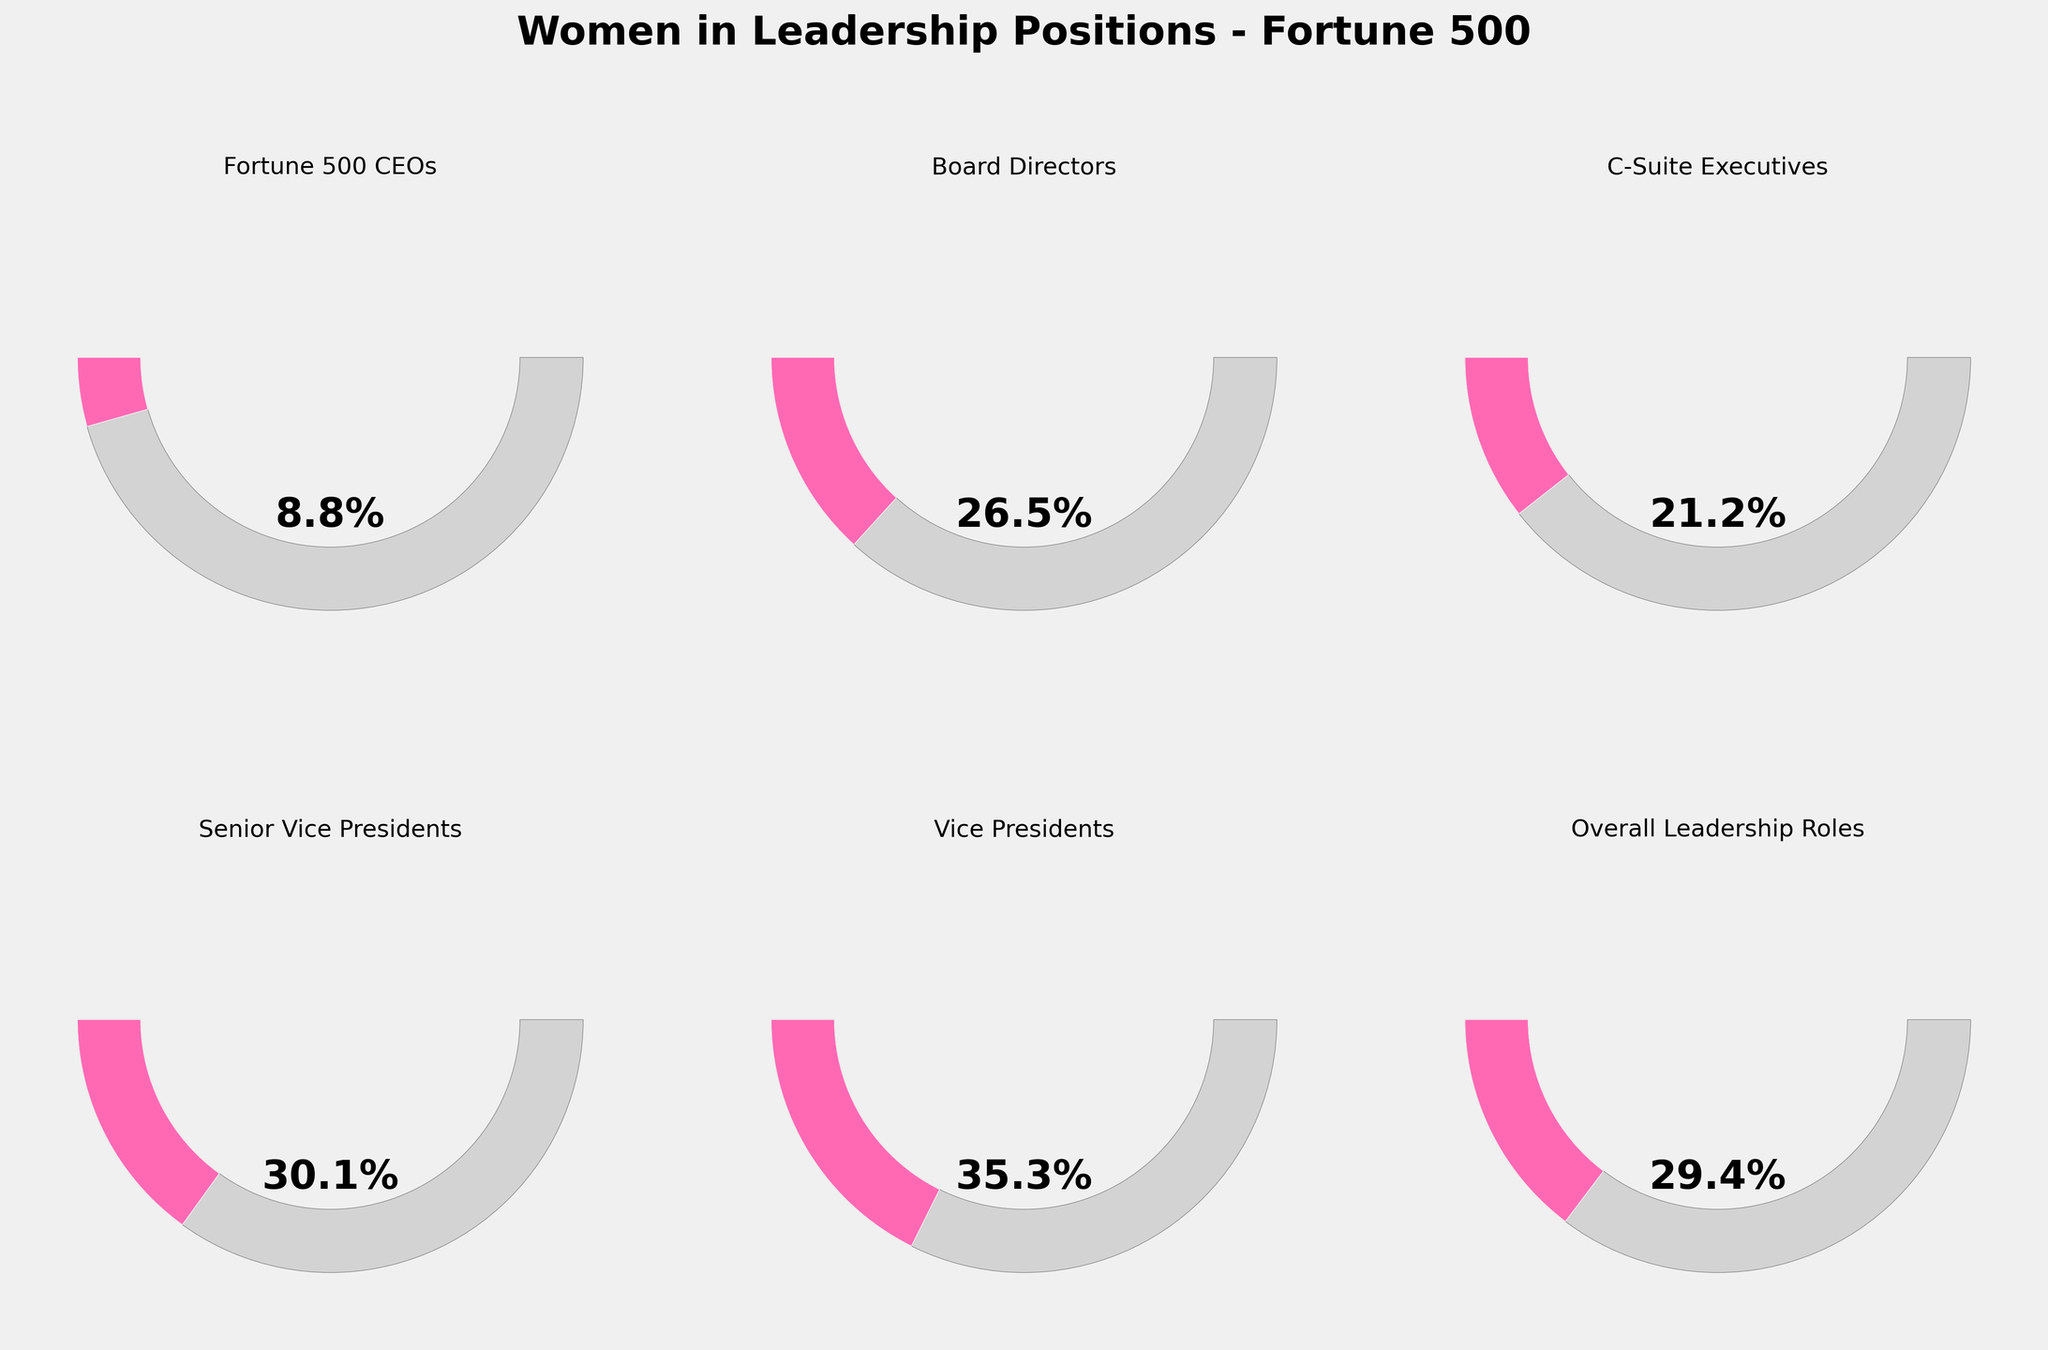What's the title of the figure? The title is found at the top of the figure, usually in a larger, bold font to make it easily identifiable. It summarizes the main subject of the chart. In this figure, it reads "Women in Leadership Positions - Fortune 500".
Answer: Women in Leadership Positions - Fortune 500 What color represents the filled percentage in the gauge charts? The filled percentage of each gauge chart is represented by a distinct color. In this figure, the color used is pink.
Answer: Pink Which category has the smallest percentage of women in leadership roles? By examining the different gauge charts, we can see that the category with the smallest filled arc corresponds to "Fortune 500 CEOs", showing only 8.8%.
Answer: Fortune 500 CEOs What's the percentage of women in Vice President positions? The gauge chart labeled "Vice Presidents" shows the percentage value inside the chart. It reads 35.3%, indicating the percentage of women in those roles.
Answer: 35.3% How many categories are displayed in the figure? By counting the individual gauge charts, we can see that there are six different categories presented.
Answer: Six Which category has the highest percentage of women in leadership positions? By examining the gauge charts, we can see that "Vice Presidents" has the highest percentage, showing a filled arc up to 35.3%.
Answer: Vice Presidents What is the combined percentage of women in Senior Vice President and Board Director roles? The percentages for Senior Vice Presidents and Board Directors are 30.1% and 26.5% respectively. Adding them together: 30.1 + 26.5 = 56.6%.
Answer: 56.6% Is the percentage of women in C-Suite Executives greater than the percentage of women in Overall Leadership Roles? The percentage in C-Suite Executives is 21.2%, while in Overall Leadership Roles it's 29.4%. Since 21.2% is less than 29.4%, the answer is no.
Answer: No How much lower is the percentage of women as Fortune 500 CEOs compared to Vice Presidents? The percentage of women as Fortune 500 CEOs is 8.8%, while for Vice Presidents it's 35.3%. The difference is 35.3 - 8.8 = 26.5%.
Answer: 26.5% 